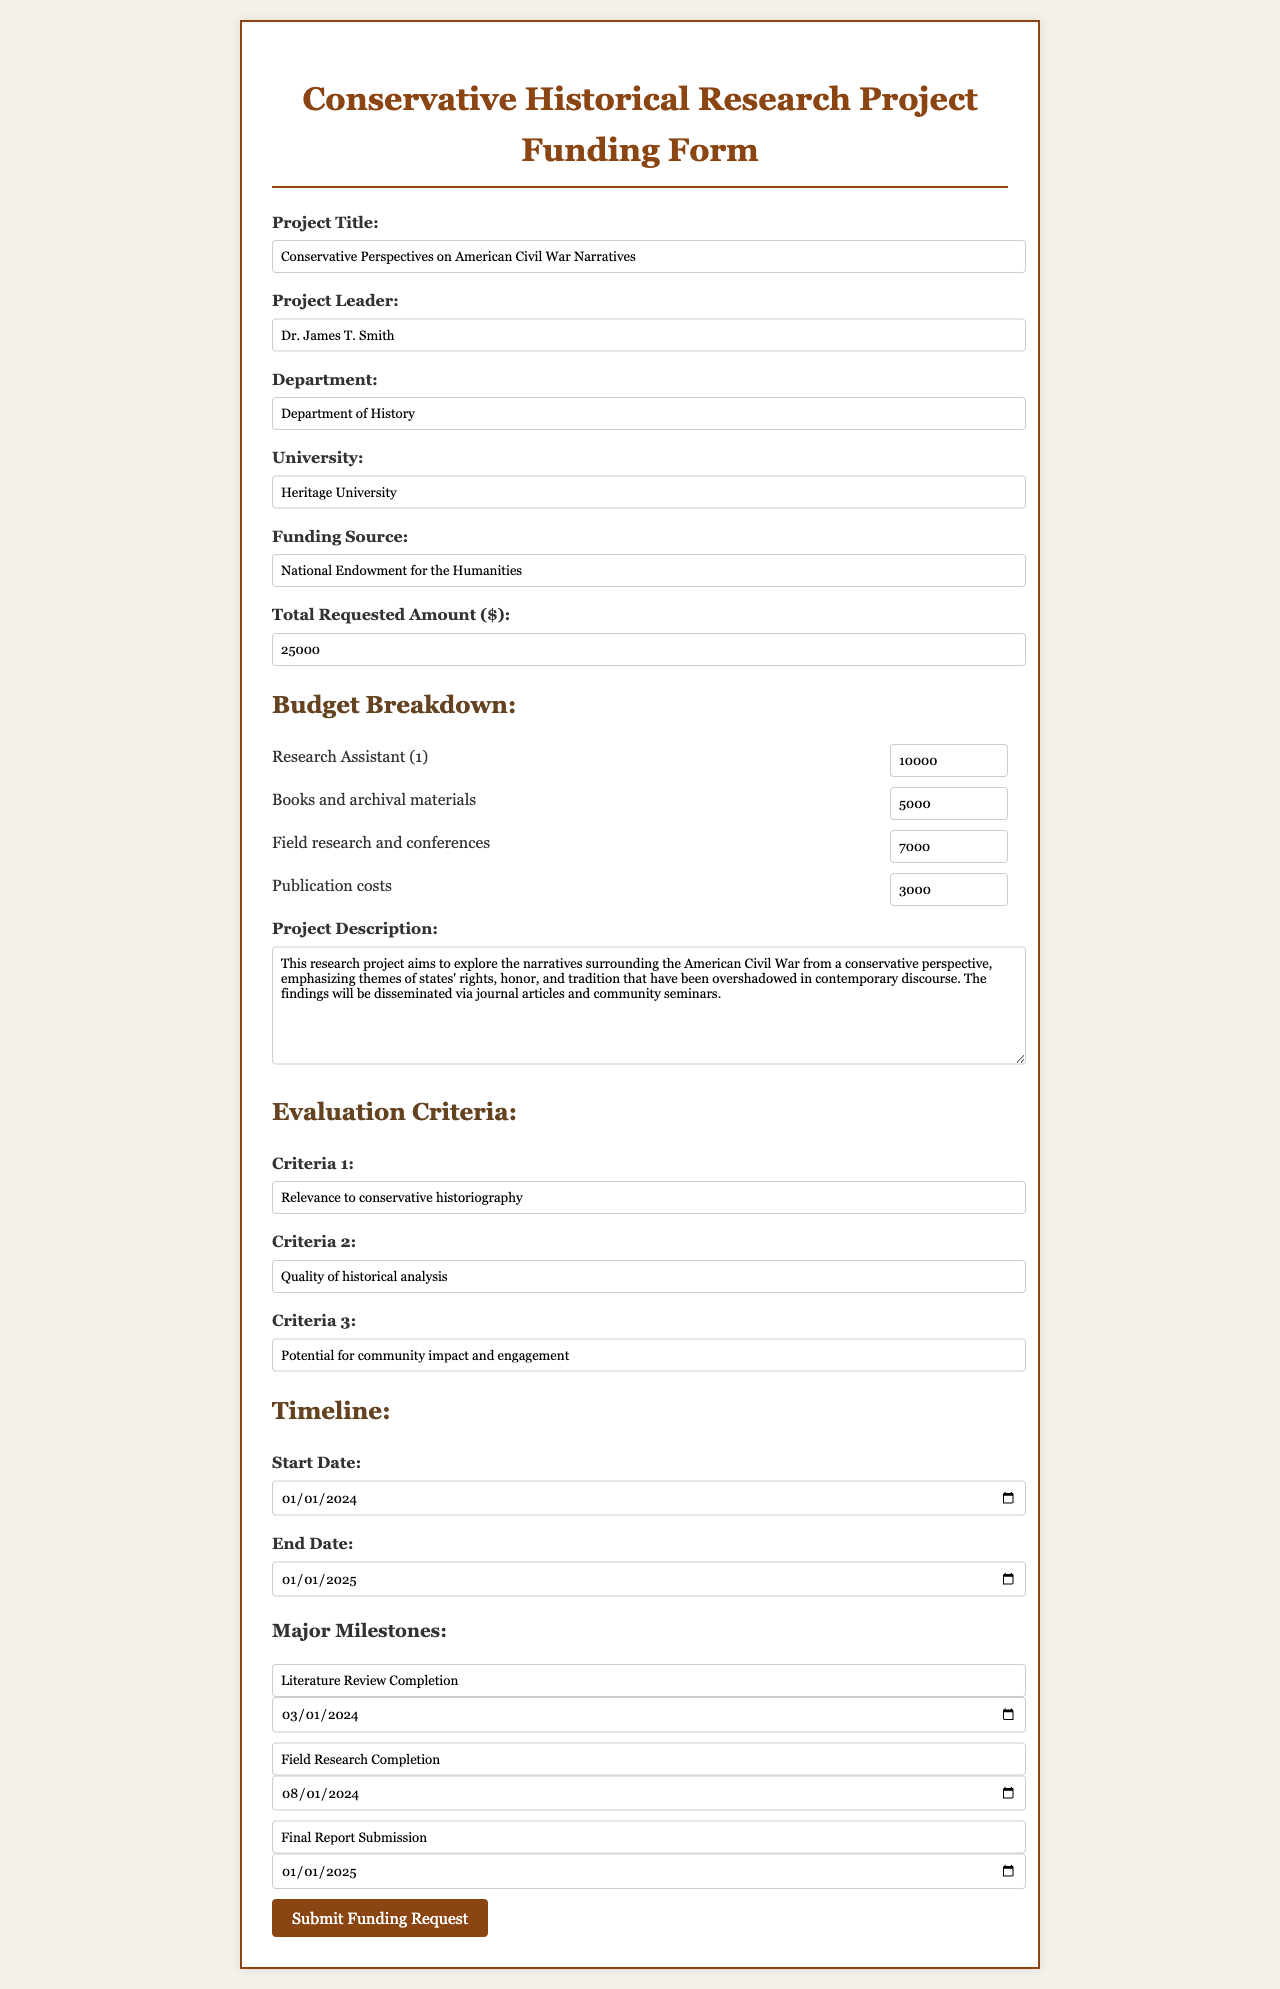what is the project title? The project title is listed in the form under the Project Title section.
Answer: Conservative Perspectives on American Civil War Narratives who is the project leader? The project leader’s name is provided in the form under the Project Leader section.
Answer: Dr. James T. Smith what is the total requested amount? The total requested amount can be found in the Total Requested Amount section of the budget form.
Answer: 25000 what is the funding source? The funding source is indicated in the Funding Source section of the form.
Answer: National Endowment for the Humanities what is the start date of the project? The start date is specified in the Timeline section of the form.
Answer: 2024-01-01 what are the criteria for evaluation? The evaluation criteria are listed in the Evaluation Criteria section, requiring understanding of multiple criteria presented.
Answer: Relevance to conservative historiography, Quality of historical analysis, Potential for community impact and engagement what is the budget allocation for books and archival materials? The budget allocation for books and archival materials is detailed in the Budget Breakdown section.
Answer: 5000 when is the final report submission date? The final report submission date is specified as a major milestone in the Timeline section.
Answer: 2025-01-01 what is the total number of milestones listed? The total number of milestones is found by counting the entries under Major Milestones in the Timeline section.
Answer: 3 